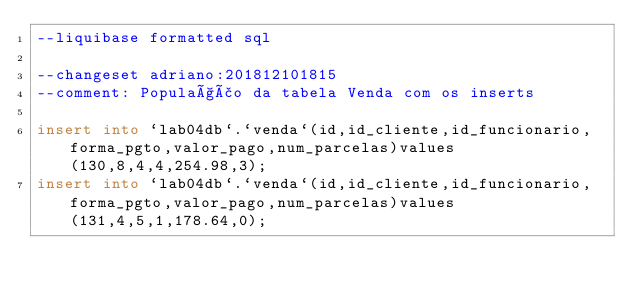Convert code to text. <code><loc_0><loc_0><loc_500><loc_500><_SQL_>--liquibase formatted sql

--changeset adriano:201812101815
--comment: População da tabela Venda com os inserts

insert into `lab04db`.`venda`(id,id_cliente,id_funcionario,forma_pgto,valor_pago,num_parcelas)values(130,8,4,4,254.98,3);
insert into `lab04db`.`venda`(id,id_cliente,id_funcionario,forma_pgto,valor_pago,num_parcelas)values(131,4,5,1,178.64,0);
</code> 